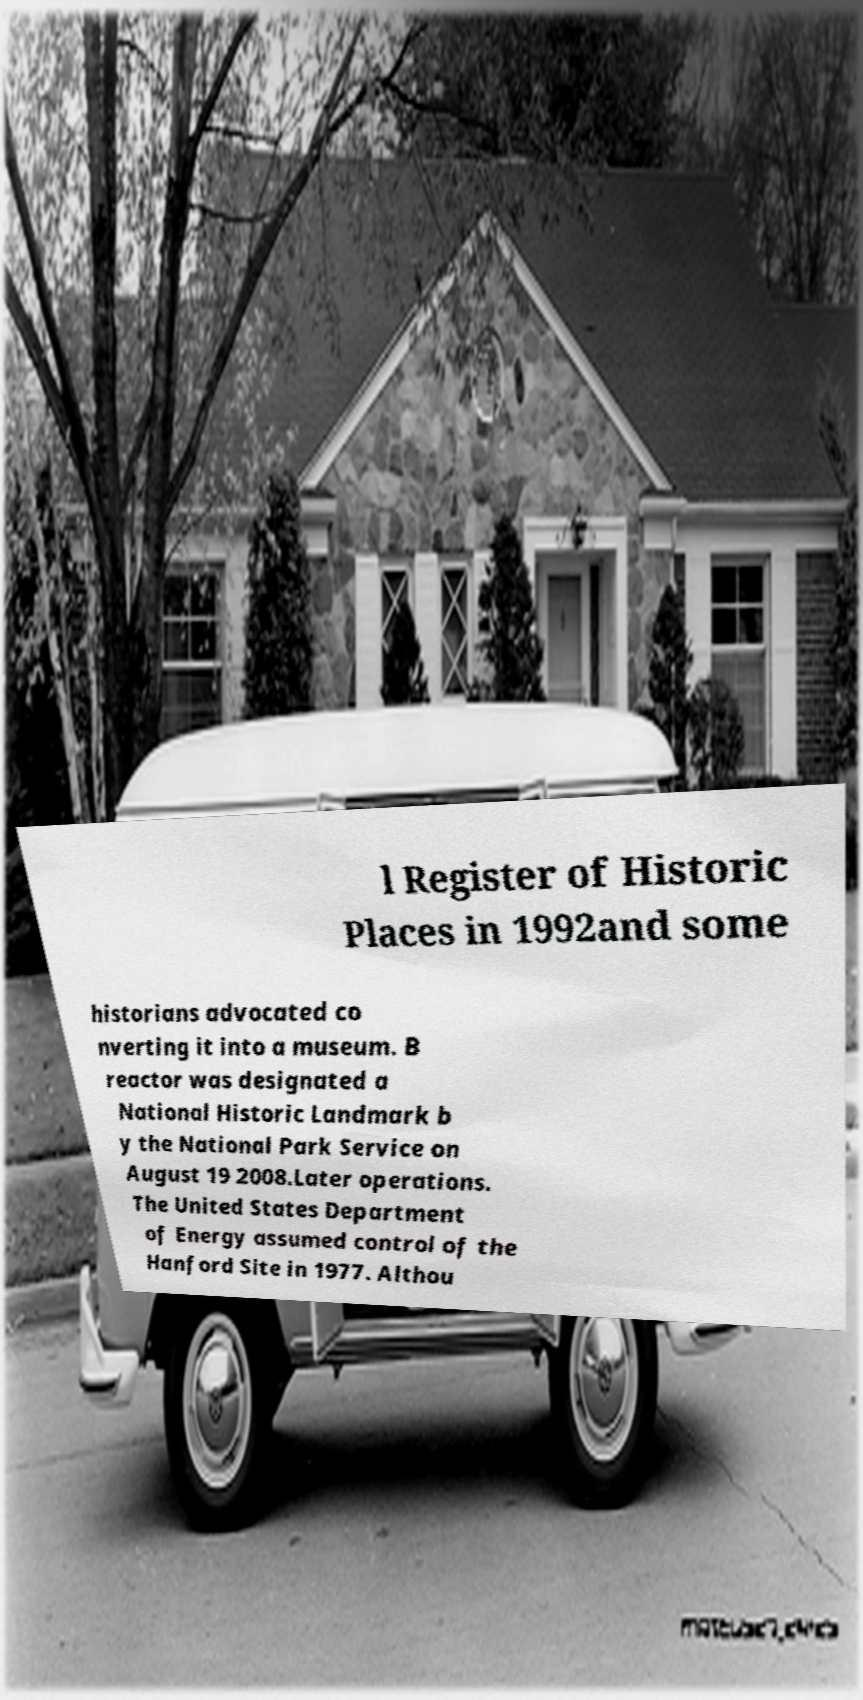Please identify and transcribe the text found in this image. l Register of Historic Places in 1992and some historians advocated co nverting it into a museum. B reactor was designated a National Historic Landmark b y the National Park Service on August 19 2008.Later operations. The United States Department of Energy assumed control of the Hanford Site in 1977. Althou 